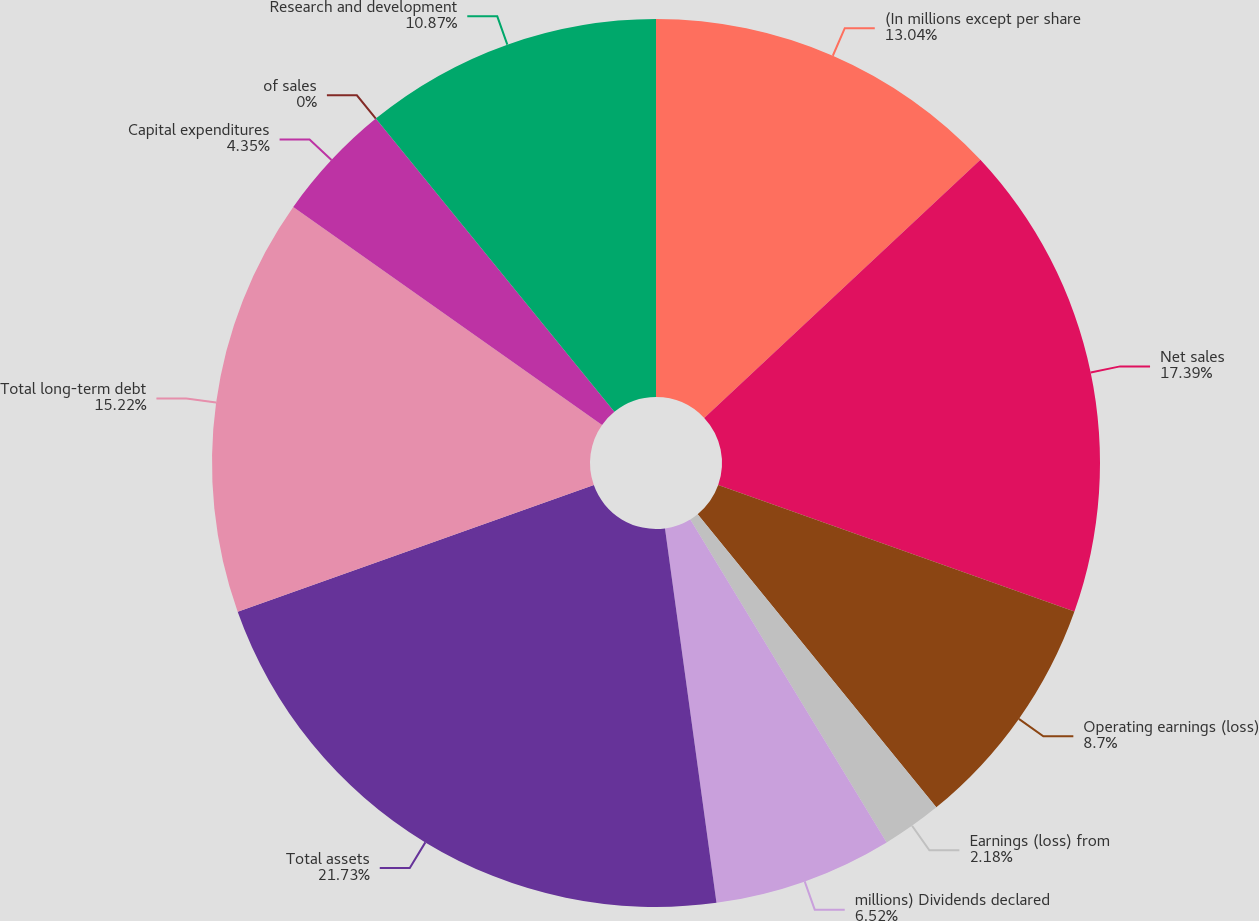Convert chart. <chart><loc_0><loc_0><loc_500><loc_500><pie_chart><fcel>(In millions except per share<fcel>Net sales<fcel>Operating earnings (loss)<fcel>Earnings (loss) from<fcel>millions) Dividends declared<fcel>Total assets<fcel>Total long-term debt<fcel>Capital expenditures<fcel>of sales<fcel>Research and development<nl><fcel>13.04%<fcel>17.39%<fcel>8.7%<fcel>2.18%<fcel>6.52%<fcel>21.74%<fcel>15.22%<fcel>4.35%<fcel>0.0%<fcel>10.87%<nl></chart> 